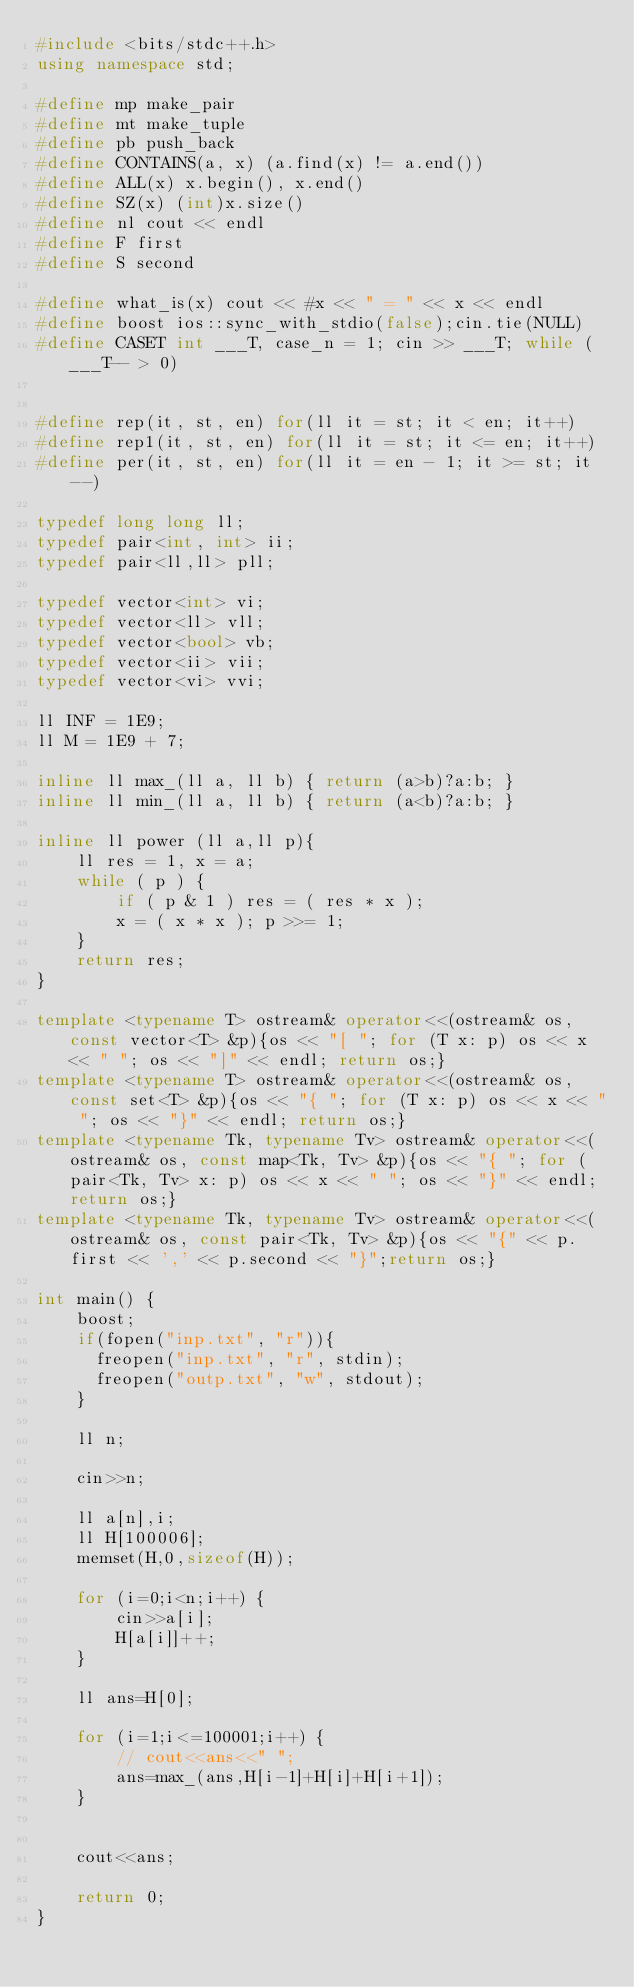Convert code to text. <code><loc_0><loc_0><loc_500><loc_500><_C++_>#include <bits/stdc++.h>
using namespace std;

#define mp make_pair
#define mt make_tuple
#define pb push_back
#define CONTAINS(a, x) (a.find(x) != a.end())
#define ALL(x) x.begin(), x.end()
#define SZ(x) (int)x.size()
#define nl cout << endl
#define F first
#define S second

#define what_is(x) cout << #x << " = " << x << endl
#define boost ios::sync_with_stdio(false);cin.tie(NULL)
#define CASET int ___T, case_n = 1; cin >> ___T; while (___T-- > 0) 


#define rep(it, st, en) for(ll it = st; it < en; it++)
#define rep1(it, st, en) for(ll it = st; it <= en; it++)
#define per(it, st, en) for(ll it = en - 1; it >= st; it--)

typedef long long ll;
typedef pair<int, int> ii;
typedef pair<ll,ll> pll;

typedef vector<int> vi;
typedef vector<ll> vll;
typedef vector<bool> vb;
typedef vector<ii> vii;
typedef vector<vi> vvi;

ll INF = 1E9;
ll M = 1E9 + 7;

inline ll max_(ll a, ll b) { return (a>b)?a:b; }
inline ll min_(ll a, ll b) { return (a<b)?a:b; }

inline ll power (ll a,ll p){
    ll res = 1, x = a;
    while ( p ) {
        if ( p & 1 ) res = ( res * x );
        x = ( x * x ); p >>= 1;
    }
    return res;
}

template <typename T> ostream& operator<<(ostream& os, const vector<T> &p){os << "[ "; for (T x: p) os << x << " "; os << "]" << endl; return os;}
template <typename T> ostream& operator<<(ostream& os, const set<T> &p){os << "{ "; for (T x: p) os << x << " "; os << "}" << endl; return os;}
template <typename Tk, typename Tv> ostream& operator<<(ostream& os, const map<Tk, Tv> &p){os << "{ "; for (pair<Tk, Tv> x: p) os << x << " "; os << "}" << endl; return os;}
template <typename Tk, typename Tv> ostream& operator<<(ostream& os, const pair<Tk, Tv> &p){os << "{" << p.first << ',' << p.second << "}";return os;}

int main() {
    boost;
    if(fopen("inp.txt", "r")){
      freopen("inp.txt", "r", stdin);
      freopen("outp.txt", "w", stdout);
    }

    ll n;

    cin>>n;

    ll a[n],i;
    ll H[100006];
    memset(H,0,sizeof(H));

    for (i=0;i<n;i++) {
        cin>>a[i];
        H[a[i]]++;
    }

    ll ans=H[0];

    for (i=1;i<=100001;i++) {
        // cout<<ans<<" ";
        ans=max_(ans,H[i-1]+H[i]+H[i+1]);
    }


    cout<<ans;

    return 0;
}</code> 